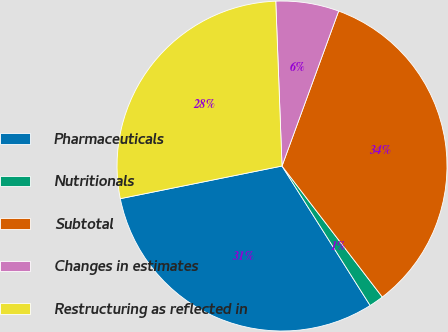Convert chart to OTSL. <chart><loc_0><loc_0><loc_500><loc_500><pie_chart><fcel>Pharmaceuticals<fcel>Nutritionals<fcel>Subtotal<fcel>Changes in estimates<fcel>Restructuring as reflected in<nl><fcel>30.8%<fcel>1.43%<fcel>34.03%<fcel>6.18%<fcel>27.57%<nl></chart> 